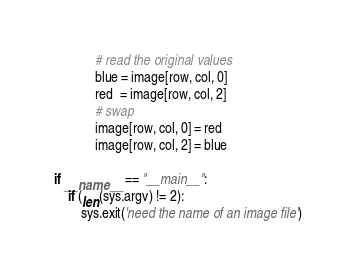<code> <loc_0><loc_0><loc_500><loc_500><_Python_>            # read the original values
            blue = image[row, col, 0]
            red  = image[row, col, 2]
            # swap
            image[row, col, 0] = red
            image[row, col, 2] = blue
            
if __name__ == "__main__":
    if (len(sys.argv) != 2):
        sys.exit('need the name of an image file')</code> 